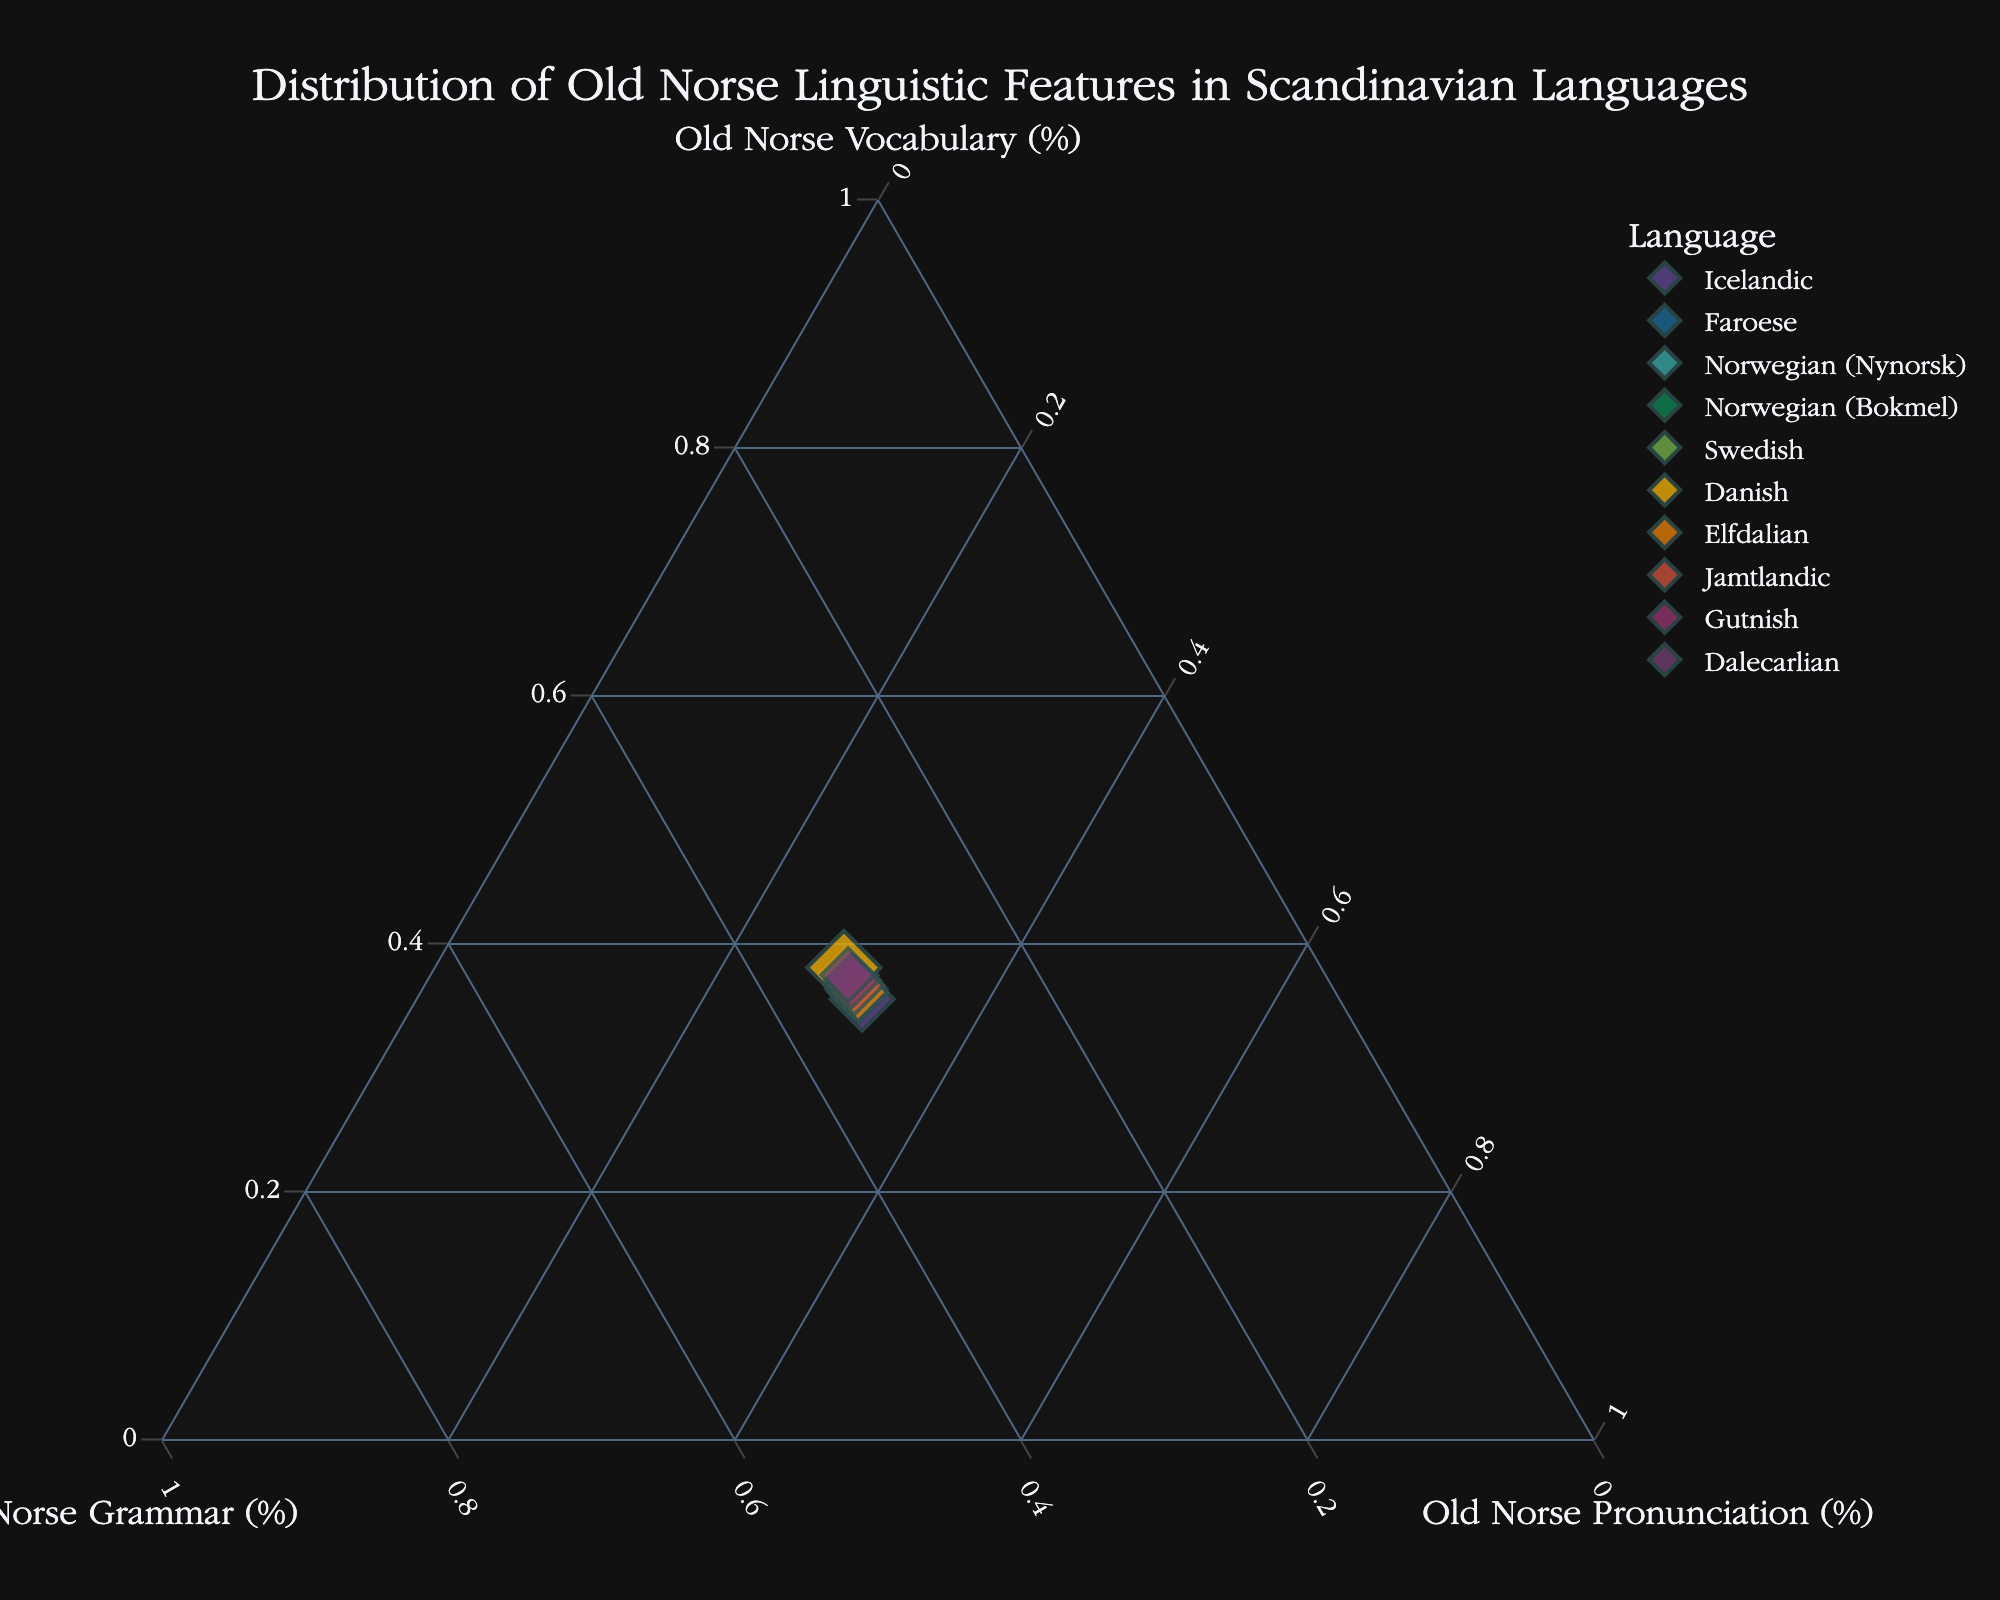What's the title of the plot? The title of the plot is located at the top-center and is in a larger font size compared to the rest of the text. It reads "Distribution of Old Norse Linguistic Features in Scandinavian Languages".
Answer: Distribution of Old Norse Linguistic Features in Scandinavian Languages Which language has the highest percentage of Old Norse Vocabulary? The percentages of Old Norse Vocabulary are represented along one axis of the ternary plot. By looking for the data point closest to the 'Old Norse Vocabulary (%)' axis, we see that Icelandic has the highest percentage.
Answer: Icelandic What color represents the Swedish data point? Each data point is colored uniquely, and by checking the legend, we can identify the color corresponding to Swedish. According to the legend, Swedish is represented by a certain shade.
Answer: (Provide appropriate color based on plot's color scheme) Which language feature is most dominant in the Faroese data point? Faroese is located at a specific point in the ternary plot, and we need to look at which axis this point is closest to. Faroese is closest to 'Old Norse Vocabulary (%)', making it the dominant feature for this language.
Answer: Old Norse Vocabulary How many languages are represented in the plot? Counting the different data points represented in the ternary plot will give us the number of languages. Each unique point corresponds to a different language. There are 10 data points, so 10 languages are represented.
Answer: 10 Which language has a balanced distribution of Old Norse features (Vocabulary, Grammar, Pronunciation)? A balanced distribution would mean that a language's data point is approximately equidistant from all three axes. By visually examining the plot, we can identify which data point meets this criterion.
Answer: (Identify the most balanced one based on the visual inspection) What's the difference in Old Norse Grammar percentage between Jamtlandic and Norwegian (Nynorsk)? Look at the locations of the points for both Jamtlandic and Norwegian (Nynorsk) along the axis representing 'Old Norse Grammar (%)'. Jamtlandic is at 50%, and Norwegian (Nynorsk) is at 55%. The difference is calculated as 55% - 50%.
Answer: 5% Which language is closer to Norwegian (Nynorsk) in terms of Old Norse Pronunciation? We compare the points closest to the 'Old Norse Pronunciation (%)' axis. The closest language to Norwegian (Nynorsk) would be the one with a similar percentage on this axis. Faroese, with 60%, is close to Norwegian (Nynorsk)'s 50%.
Answer: Faroese What's the average Old Norse Pronunciation percentage for Icelandic, Faroese, and Danish? Locate the Old Norse Pronunciation percentages for Icelandic (70%), Faroese (60%), and Danish (30%). Add these values and divide by 3 to get the average: (70 + 60 + 30) / 3.
Answer: 53% Which language has the smallest size marker on the plot? Marker size can be visually compared in the plot. The data point with the smallest size marker is the one with the lowest size value.
Answer: (Identify based on visual inspection of sizes in the plot) 